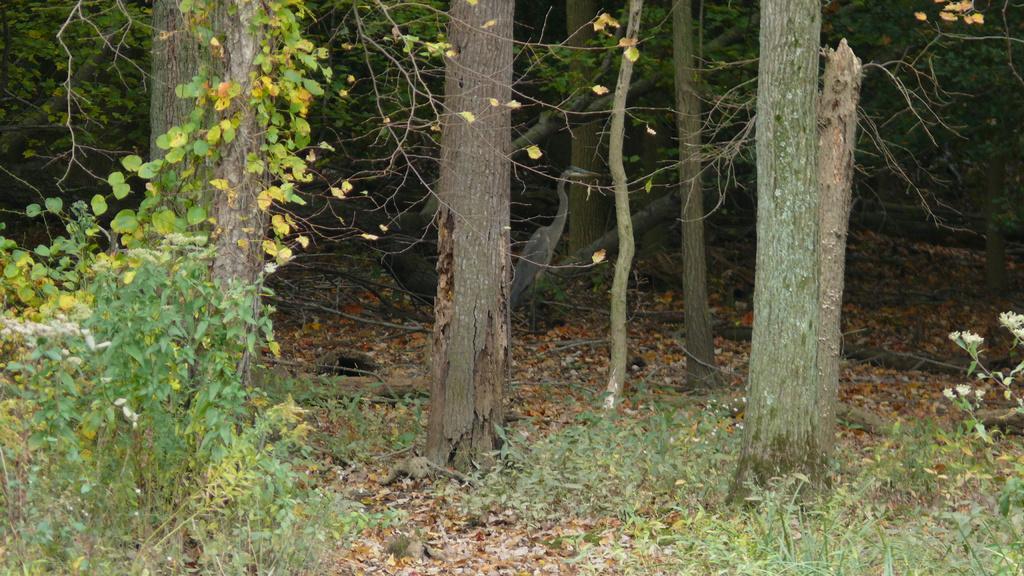How would you summarize this image in a sentence or two? In this image we can see few trees, plants and a bird on the ground. 